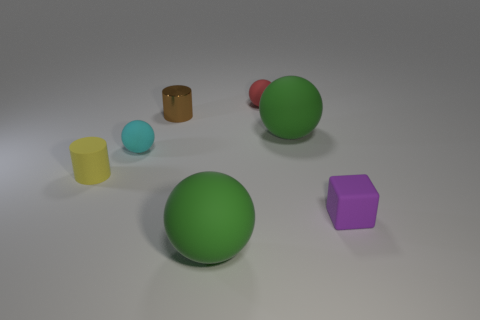How many small yellow cylinders have the same material as the cyan sphere?
Offer a terse response. 1. How many rubber things are either big yellow objects or red balls?
Your answer should be compact. 1. Does the small cyan object behind the cube have the same shape as the big green rubber object behind the small yellow rubber cylinder?
Your response must be concise. Yes. There is a tiny matte object that is behind the yellow rubber thing and in front of the tiny red rubber thing; what color is it?
Give a very brief answer. Cyan. There is a ball behind the tiny brown cylinder; is its size the same as the rubber ball on the left side of the tiny brown cylinder?
Ensure brevity in your answer.  Yes. What number of big rubber balls are the same color as the metallic cylinder?
Offer a very short reply. 0. How many tiny objects are either red things or brown cylinders?
Your answer should be compact. 2. Does the ball in front of the purple object have the same material as the tiny red object?
Your answer should be compact. Yes. What is the color of the large matte sphere that is on the right side of the small red thing?
Your answer should be compact. Green. Are there any metal objects of the same size as the purple matte cube?
Offer a very short reply. Yes. 